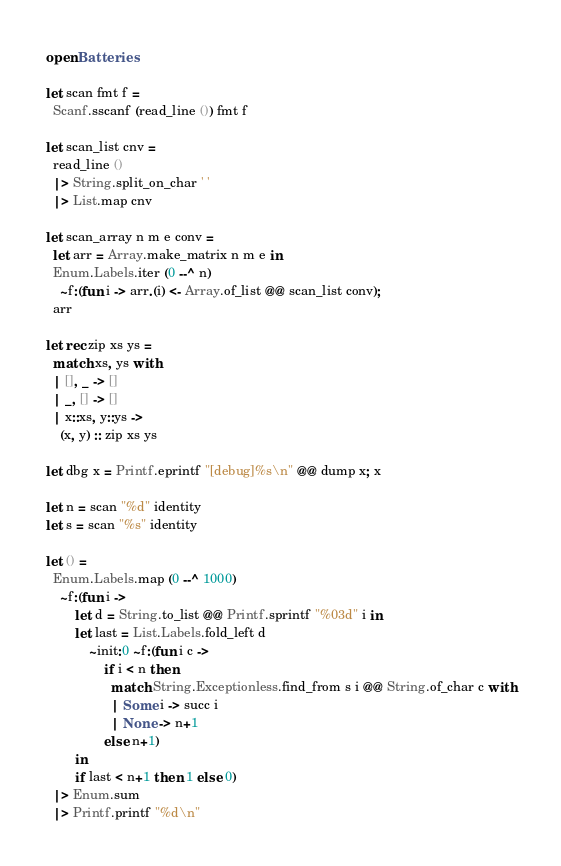Convert code to text. <code><loc_0><loc_0><loc_500><loc_500><_OCaml_>open Batteries

let scan fmt f =
  Scanf.sscanf (read_line ()) fmt f

let scan_list cnv =
  read_line ()
  |> String.split_on_char ' '
  |> List.map cnv

let scan_array n m e conv =
  let arr = Array.make_matrix n m e in
  Enum.Labels.iter (0 --^ n)
    ~f:(fun i -> arr.(i) <- Array.of_list @@ scan_list conv);
  arr

let rec zip xs ys =
  match xs, ys with
  | [], _ -> []
  | _, [] -> []
  | x::xs, y::ys ->
    (x, y) :: zip xs ys

let dbg x = Printf.eprintf "[debug]%s\n" @@ dump x; x

let n = scan "%d" identity
let s = scan "%s" identity

let () =
  Enum.Labels.map (0 --^ 1000)
    ~f:(fun i ->
        let d = String.to_list @@ Printf.sprintf "%03d" i in
        let last = List.Labels.fold_left d
            ~init:0 ~f:(fun i c ->
                if i < n then
                  match String.Exceptionless.find_from s i @@ String.of_char c with
                  | Some i -> succ i
                  | None -> n+1
                else n+1)
        in
        if last < n+1 then 1 else 0)
  |> Enum.sum
  |> Printf.printf "%d\n"
</code> 